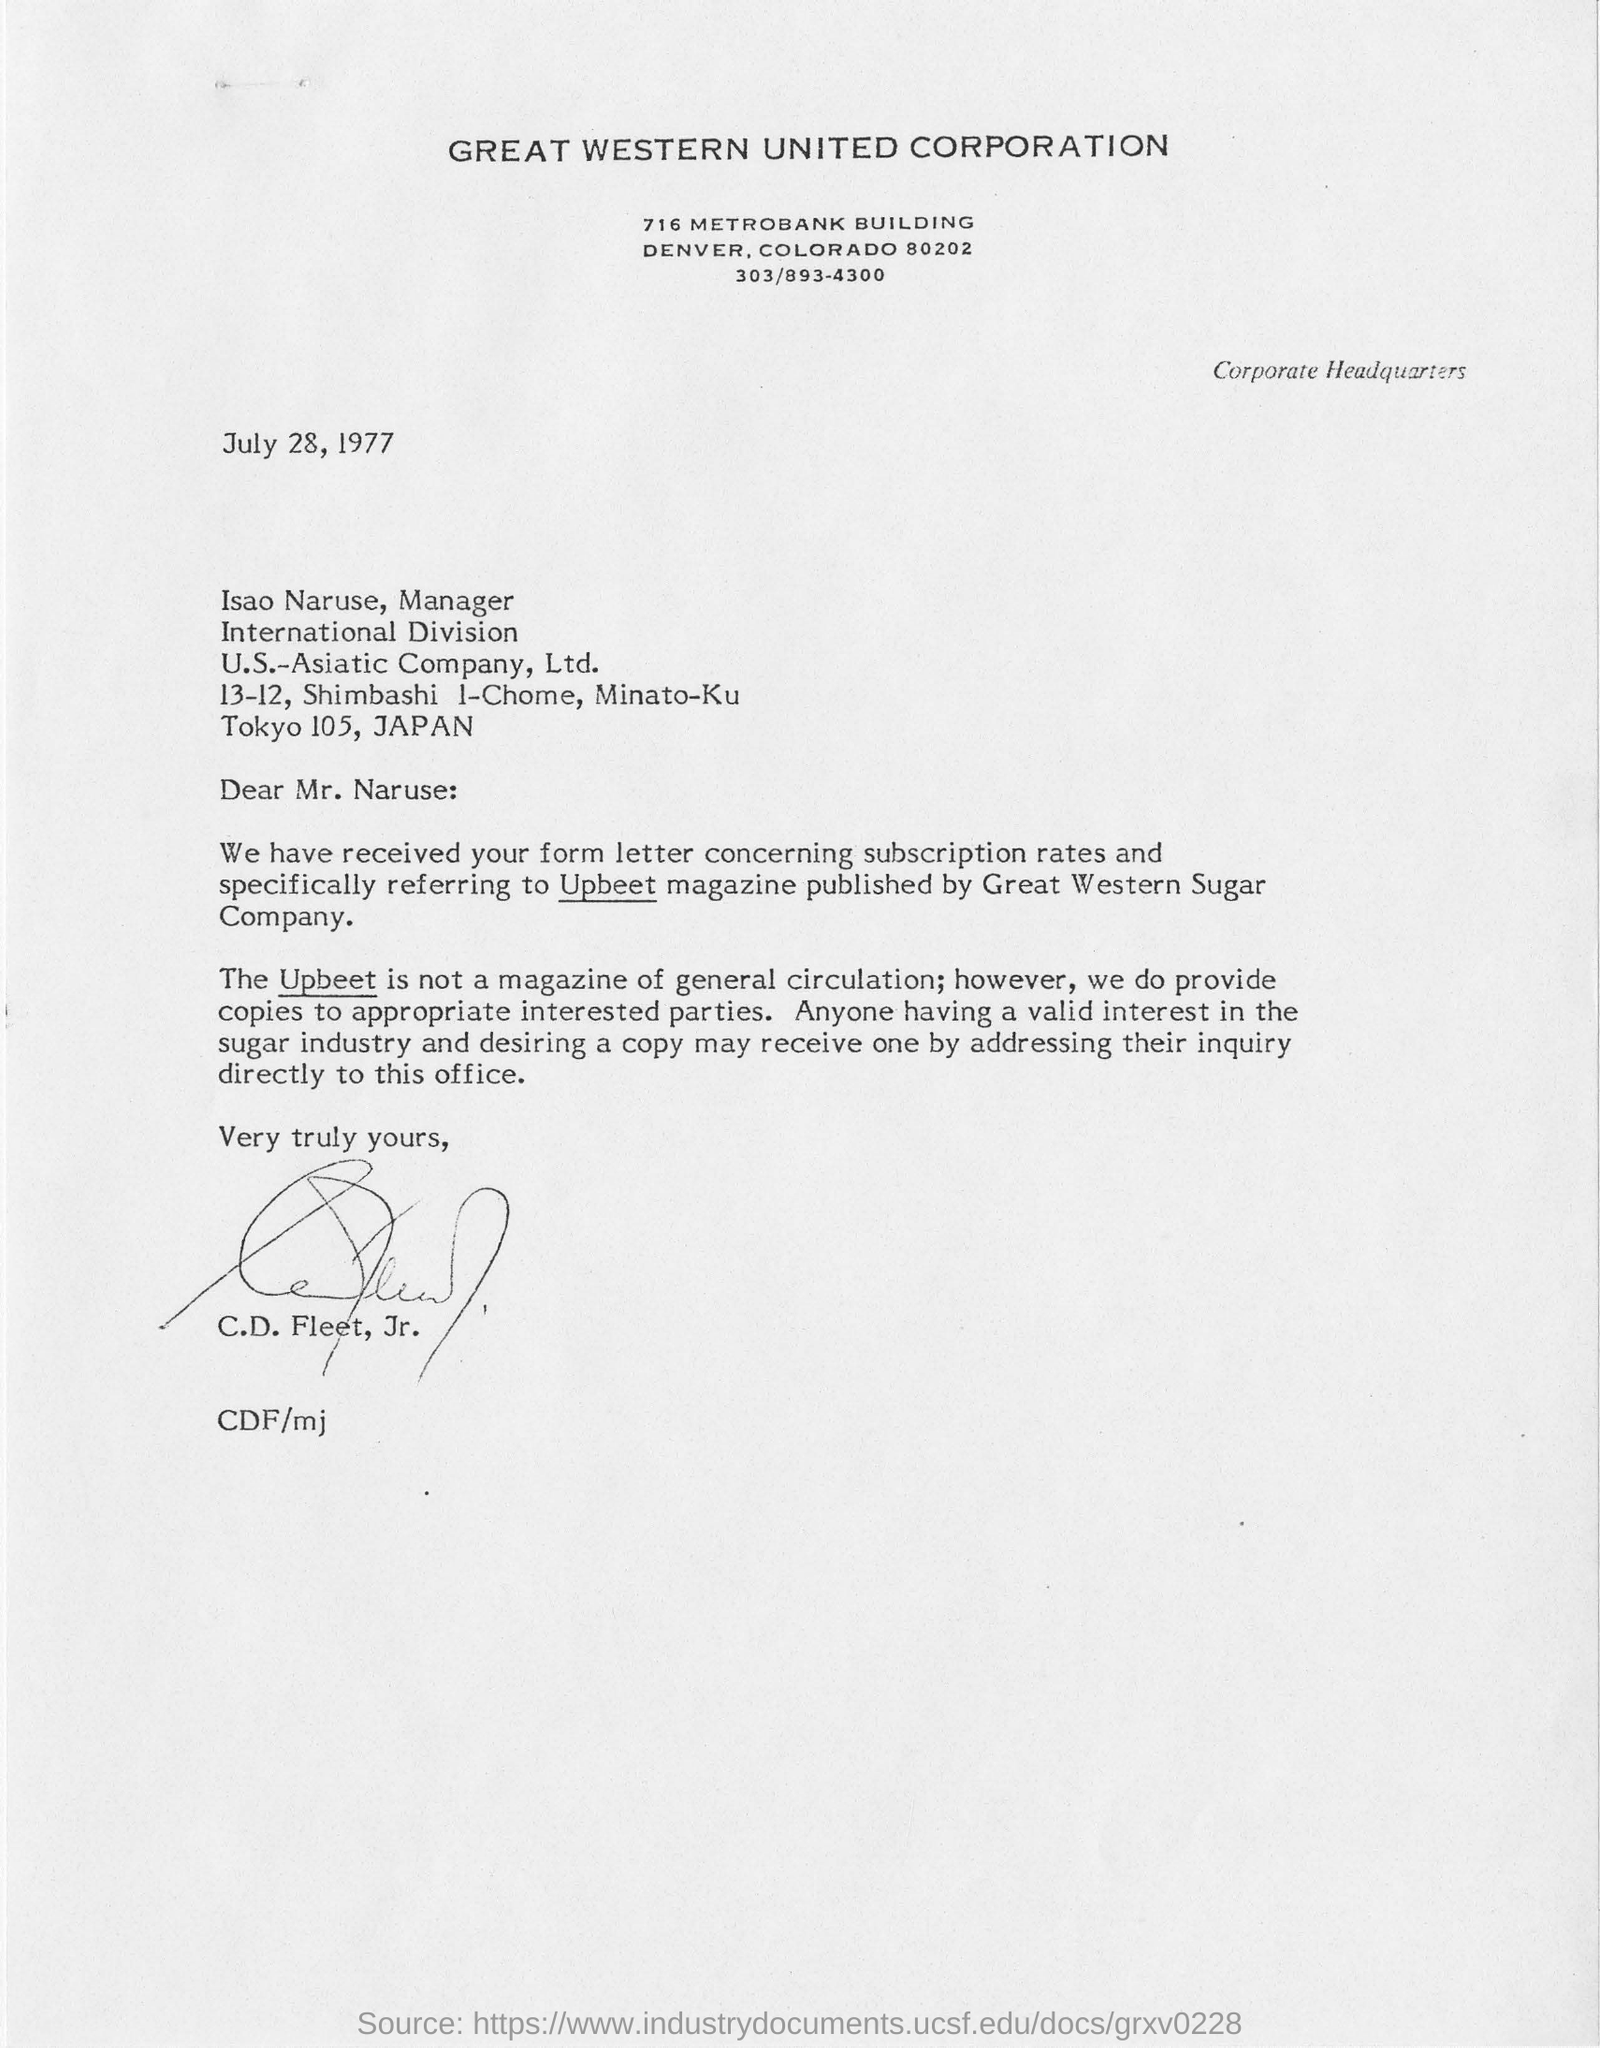Point out several critical features in this image. The letter is dated July 28, 1977. The U.S-Asiatic Company Ltd. is located in Japan. The Great Western Sugar Company publishes a magazine called Upbeet. The Great Western United Corporation is located in the state of Colorado. Isao Naruse is the manager of U.S.-Asiatic Company, Ltd. 